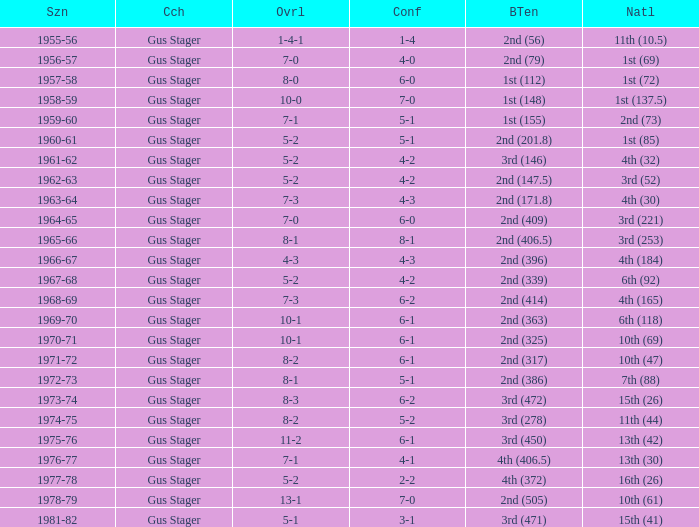What is the Season with a Big Ten that is 2nd (386)? 1972-73. 